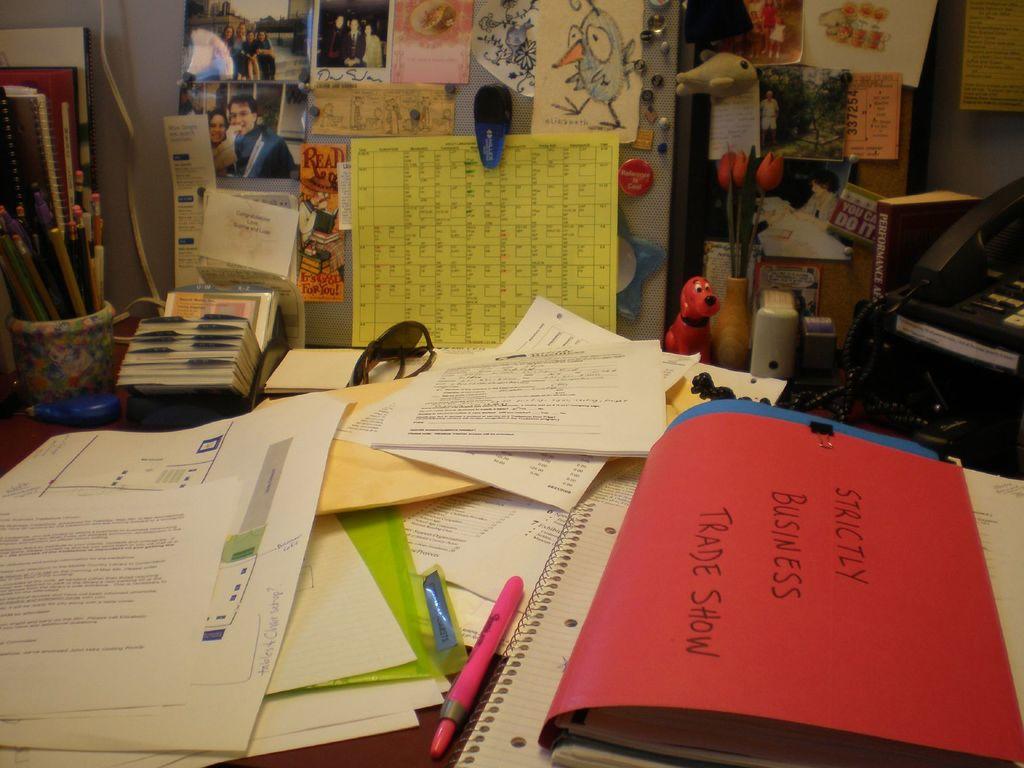What is the title of the trade show file?
Your answer should be compact. Strictly business. What is the word on the red book?
Provide a succinct answer. Strictly business trade show. 